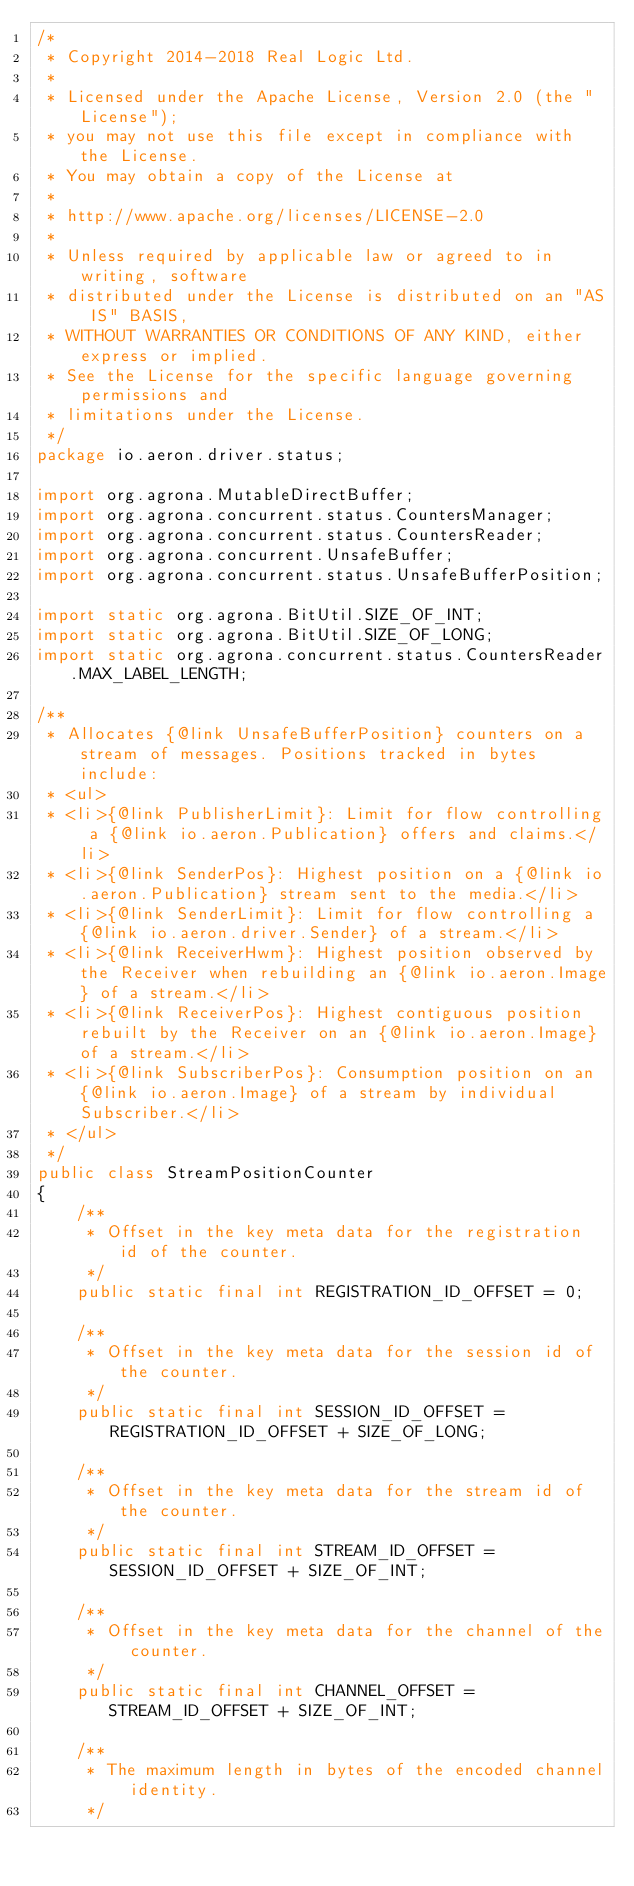<code> <loc_0><loc_0><loc_500><loc_500><_Java_>/*
 * Copyright 2014-2018 Real Logic Ltd.
 *
 * Licensed under the Apache License, Version 2.0 (the "License");
 * you may not use this file except in compliance with the License.
 * You may obtain a copy of the License at
 *
 * http://www.apache.org/licenses/LICENSE-2.0
 *
 * Unless required by applicable law or agreed to in writing, software
 * distributed under the License is distributed on an "AS IS" BASIS,
 * WITHOUT WARRANTIES OR CONDITIONS OF ANY KIND, either express or implied.
 * See the License for the specific language governing permissions and
 * limitations under the License.
 */
package io.aeron.driver.status;

import org.agrona.MutableDirectBuffer;
import org.agrona.concurrent.status.CountersManager;
import org.agrona.concurrent.status.CountersReader;
import org.agrona.concurrent.UnsafeBuffer;
import org.agrona.concurrent.status.UnsafeBufferPosition;

import static org.agrona.BitUtil.SIZE_OF_INT;
import static org.agrona.BitUtil.SIZE_OF_LONG;
import static org.agrona.concurrent.status.CountersReader.MAX_LABEL_LENGTH;

/**
 * Allocates {@link UnsafeBufferPosition} counters on a stream of messages. Positions tracked in bytes include:
 * <ul>
 * <li>{@link PublisherLimit}: Limit for flow controlling a {@link io.aeron.Publication} offers and claims.</li>
 * <li>{@link SenderPos}: Highest position on a {@link io.aeron.Publication} stream sent to the media.</li>
 * <li>{@link SenderLimit}: Limit for flow controlling a {@link io.aeron.driver.Sender} of a stream.</li>
 * <li>{@link ReceiverHwm}: Highest position observed by the Receiver when rebuilding an {@link io.aeron.Image} of a stream.</li>
 * <li>{@link ReceiverPos}: Highest contiguous position rebuilt by the Receiver on an {@link io.aeron.Image} of a stream.</li>
 * <li>{@link SubscriberPos}: Consumption position on an {@link io.aeron.Image} of a stream by individual Subscriber.</li>
 * </ul>
 */
public class StreamPositionCounter
{
    /**
     * Offset in the key meta data for the registration id of the counter.
     */
    public static final int REGISTRATION_ID_OFFSET = 0;

    /**
     * Offset in the key meta data for the session id of the counter.
     */
    public static final int SESSION_ID_OFFSET = REGISTRATION_ID_OFFSET + SIZE_OF_LONG;

    /**
     * Offset in the key meta data for the stream id of the counter.
     */
    public static final int STREAM_ID_OFFSET = SESSION_ID_OFFSET + SIZE_OF_INT;

    /**
     * Offset in the key meta data for the channel of the counter.
     */
    public static final int CHANNEL_OFFSET = STREAM_ID_OFFSET + SIZE_OF_INT;

    /**
     * The maximum length in bytes of the encoded channel identity.
     */</code> 